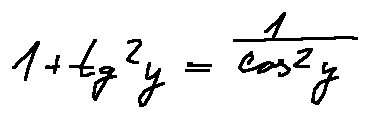Convert formula to latex. <formula><loc_0><loc_0><loc_500><loc_500>1 + \tan ^ { 2 } y = \frac { 1 } { \cos ^ { 2 } y }</formula> 